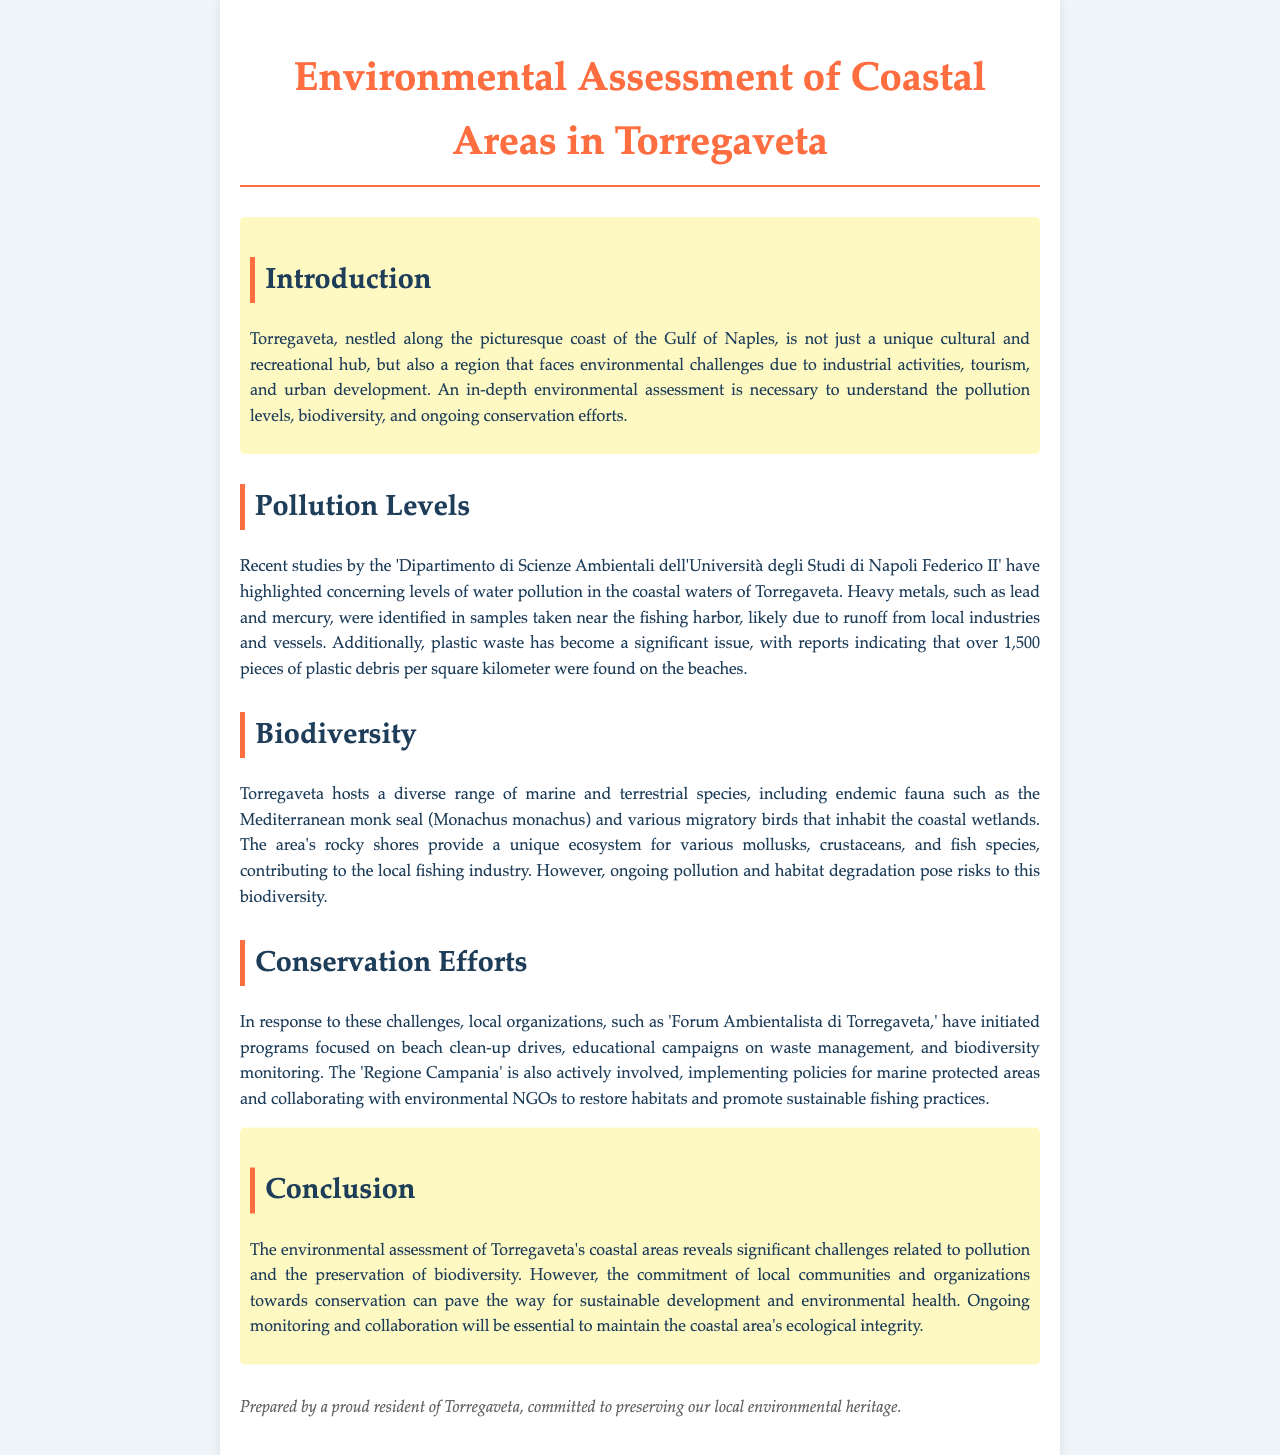What is the main environmental issue highlighted in Torregaveta? The document mentions concerning levels of water pollution as a significant environmental issue in Torregaveta.
Answer: water pollution Which heavy metals were identified in the coastal waters of Torregaveta? The assessment identifies lead and mercury as heavy metals found in the coastal waters.
Answer: lead and mercury How many pieces of plastic debris were found per square kilometer on the beaches? The report specifically states that over 1,500 pieces of plastic debris per square kilometer were found.
Answer: 1,500 What species is mentioned as an example of endemic fauna in Torregaveta? The Mediterranean monk seal is provided as an example of endemic fauna in the area.
Answer: Mediterranean monk seal What organization is mentioned as being involved in conservation efforts? The 'Forum Ambientalista di Torregaveta' is highlighted as an organization initiating conservation programs.
Answer: Forum Ambientalista di Torregaveta Why is biodiversity at risk in Torregaveta? Ongoing pollution and habitat degradation are noted as the risks to biodiversity in the region.
Answer: pollution and habitat degradation What type of policies is Regione Campania implementing? The document states that Regione Campania is implementing policies for marine protected areas.
Answer: marine protected areas What is the primary goal of the beach clean-up drives mentioned? The main aim is to address the issue of pollution along the beaches of Torregaveta.
Answer: pollution reduction 